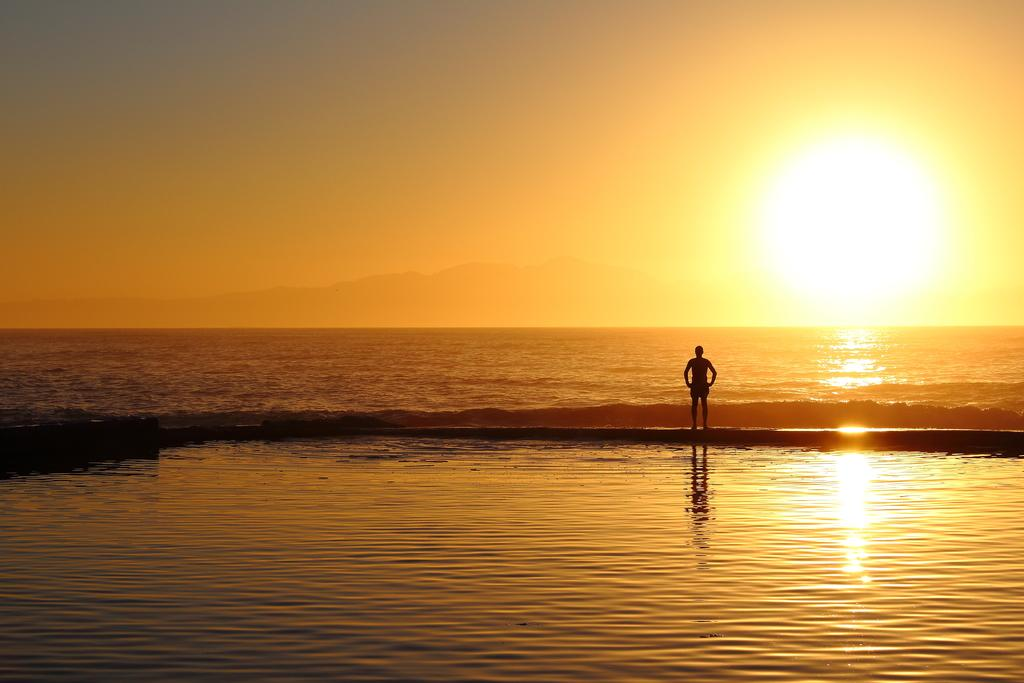What is present in the image that is not solid? There is water in the image. Can you describe the person in the image? There is a person standing in the image. What celestial body is visible in the image? The sun is visible in the image. What type of landscape can be seen in the background of the image? There are hills in the background of the image. What else is visible in the background of the image? The sky is visible in the background of the image. How many tents are set up on the hills in the image? There are no tents present in the image; it only features water, a person, the sun, hills, and the sky. What is the temperature of the water in the image? The temperature of the water cannot be determined from the image alone. 